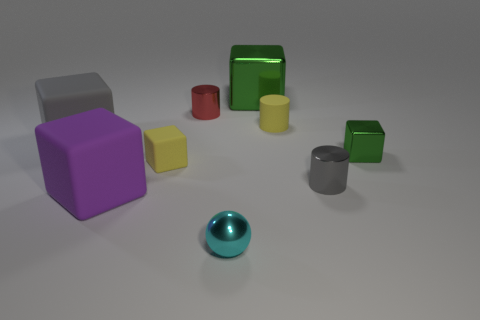What color is the other tiny rubber thing that is the same shape as the small green object? The tiny rubber item that shares its shape with the small green one is yellow. These are likely small toys or teaching aids, used for sorting by color and shape. 